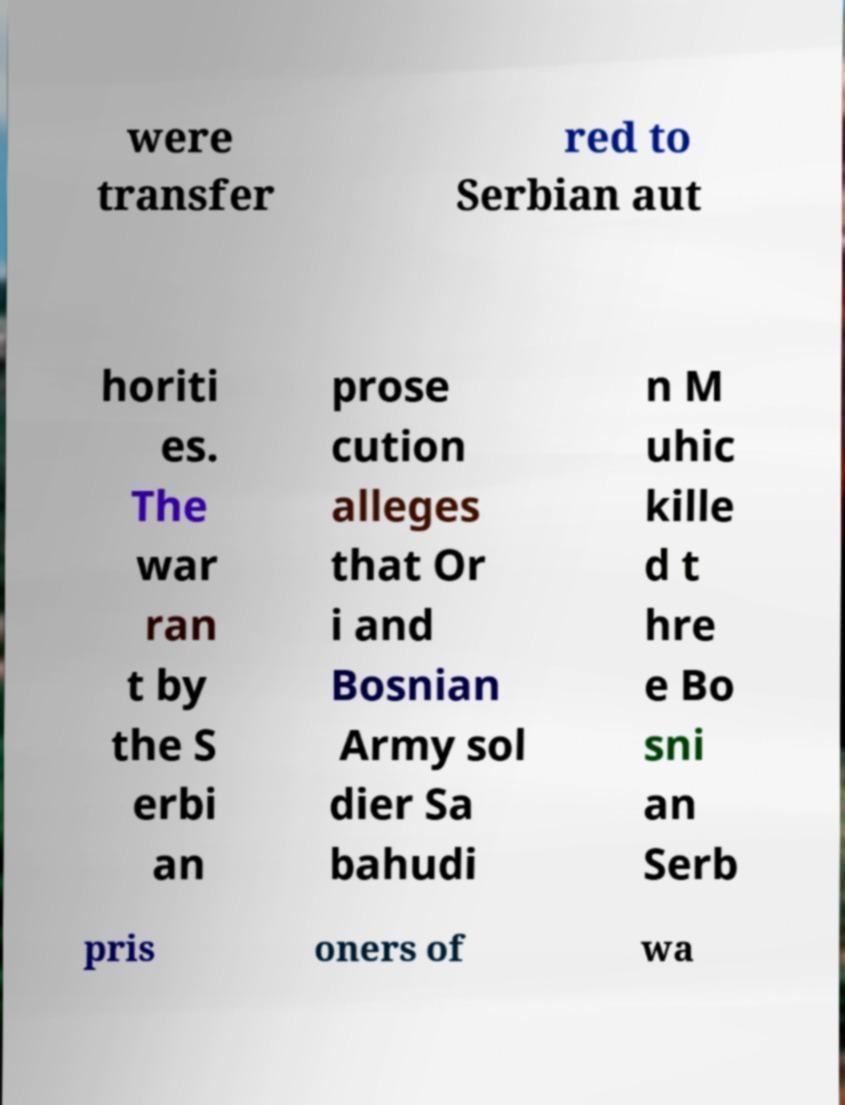Could you assist in decoding the text presented in this image and type it out clearly? were transfer red to Serbian aut horiti es. The war ran t by the S erbi an prose cution alleges that Or i and Bosnian Army sol dier Sa bahudi n M uhic kille d t hre e Bo sni an Serb pris oners of wa 